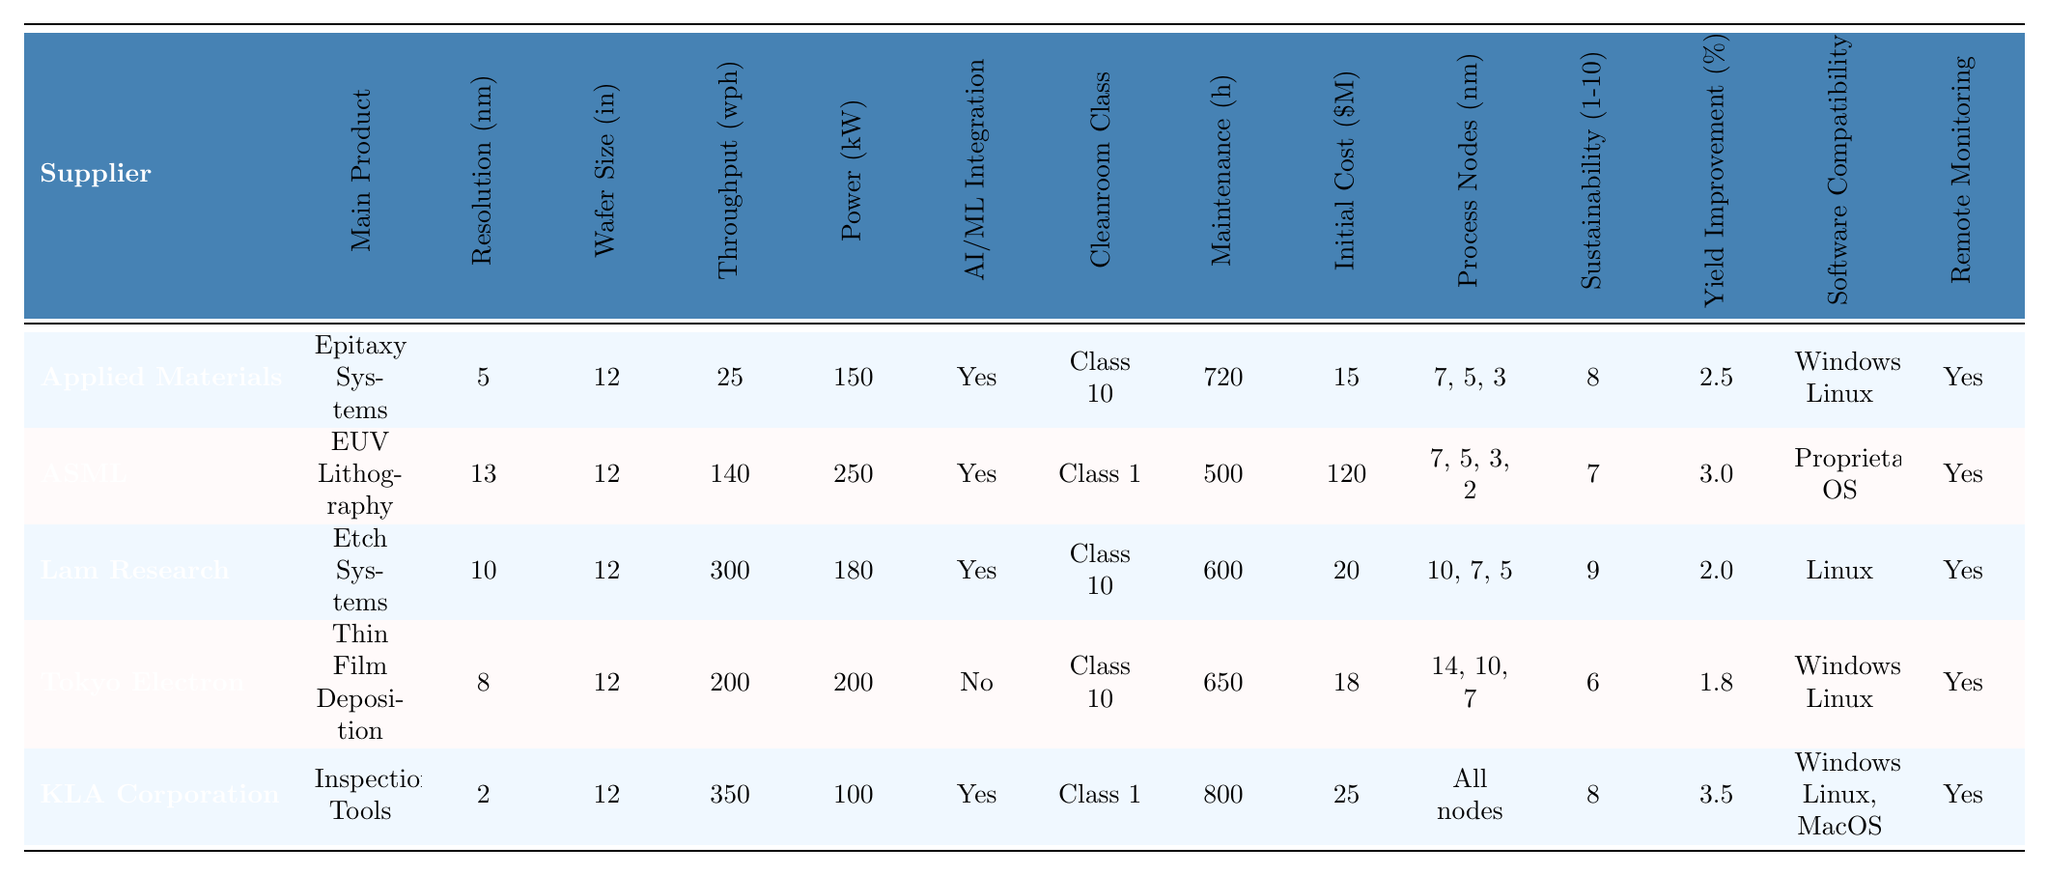What is the main product of ASML? The table specifies that the main product of ASML is "EUV Lithography."
Answer: EUV Lithography Which supplier has the highest throughput capacity? By comparing the "Throughput Capacity (wph)" values, KLA Corporation has the highest capacity at 350 wph.
Answer: KLA Corporation What is the resolution capability of Tokyo Electron? The table indicates that the resolution capability of Tokyo Electron is 8 nm.
Answer: 8 nm How much more power does ASML consume compared to KLA Corporation? ASML consumes 250 kW and KLA Corporation consumes 100 kW. The difference is 250 - 100 = 150 kW.
Answer: 150 kW Which supplier supports the widest range of process nodes? KLA Corporation supports "All nodes," indicating that it has no restrictions on the process nodes size.
Answer: KLA Corporation Is AI/ML integration available for Lam Research’s products? The table shows that Lam Research has AI/ML integration available, marked as "Yes."
Answer: Yes What is the average initial cost of the equipment from the suppliers listed? The initial costs are: 15, 120, 20, 18, and 25. The sum is 15 + 120 + 20 + 18 + 25 = 198. The average is 198 / 5 = 39.6.
Answer: 39.6 million dollars Which supplier has the best environmental sustainability score? Lam Research has the highest score of 9 out of 10 in environmental sustainability.
Answer: Lam Research How does the yield improvement of KLA Corporation compare to Tokyo Electron? KLA Corporation’s yield improvement is 3.5% while Tokyo Electron’s is 1.8%. The difference is 3.5 - 1.8 = 1.7%.
Answer: 1.7% higher Which supplier has the lowest resolution capability and what is its value? KLA Corporation has the lowest resolution capability at 2 nm.
Answer: 2 nm What is the maintenance interval for Applied Materials products? According to the table, the maintenance interval for Applied Materials is 720 hours.
Answer: 720 hours How many suppliers have AI/ML integration? The table indicates that 4 out of the 5 suppliers have AI/ML integration available.
Answer: 4 suppliers What is the power consumption comparison between the product with the highest initial cost and the one with the lowest? ASML has the highest initial cost at 120 million dollars and consumes 250 kW; KLA Corporation has the lowest initial cost at 15 million dollars and consumes 100 kW.
Answer: ASML uses 150 kW more than KLA Corporation 